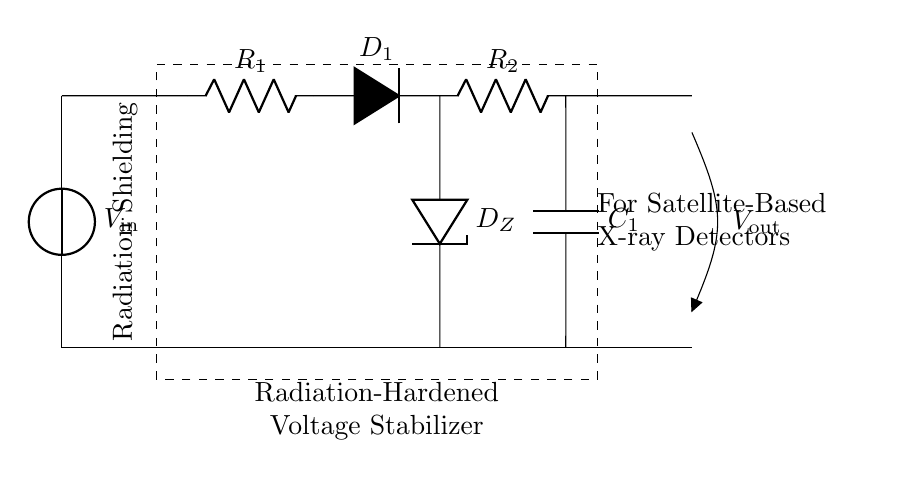What is the input voltage for the circuit? The input voltage is labeled as V_in in the circuit diagram, indicating where voltage is applied.
Answer: V_in What does the Zener diode do in this circuit? The Zener diode, labeled as D_Z, is used for voltage regulation to maintain a consistent output voltage despite variations in input or load.
Answer: Voltage regulation How many resistors are in this circuit? There are two resistors present in the circuit, indicated as R_1 and R_2, which are positioned in series with other components.
Answer: Two What is the role of the capacitor in this circuit? The capacitor, labeled as C_1, serves to smooth the output voltage by filtering any fluctuations or noise, providing stability to the output.
Answer: Smoothing Why is radiation shielding represented in this circuit? Radiation shielding is illustrated to indicate the protection of sensitive components from detrimental effects of radiation, especially critical for satellite applications.
Answer: Protection from radiation What type of diode is used for protection in the circuit? The circuit uses a standard diode, labeled as D_1, which is likely for reverse polarity protection or similar functions to safeguard the components.
Answer: Standard diode Where does the output voltage appear in this circuit? The output voltage, labeled as V_out, is obtained from the point after the capacitor, indicating it is the stabilized voltage supplied to other components.
Answer: V_out 